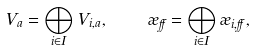Convert formula to latex. <formula><loc_0><loc_0><loc_500><loc_500>V _ { a } = \bigoplus _ { i \in I } V _ { i , a } , \quad \rho _ { \alpha } = \bigoplus _ { i \in I } \rho _ { i , \alpha } ,</formula> 